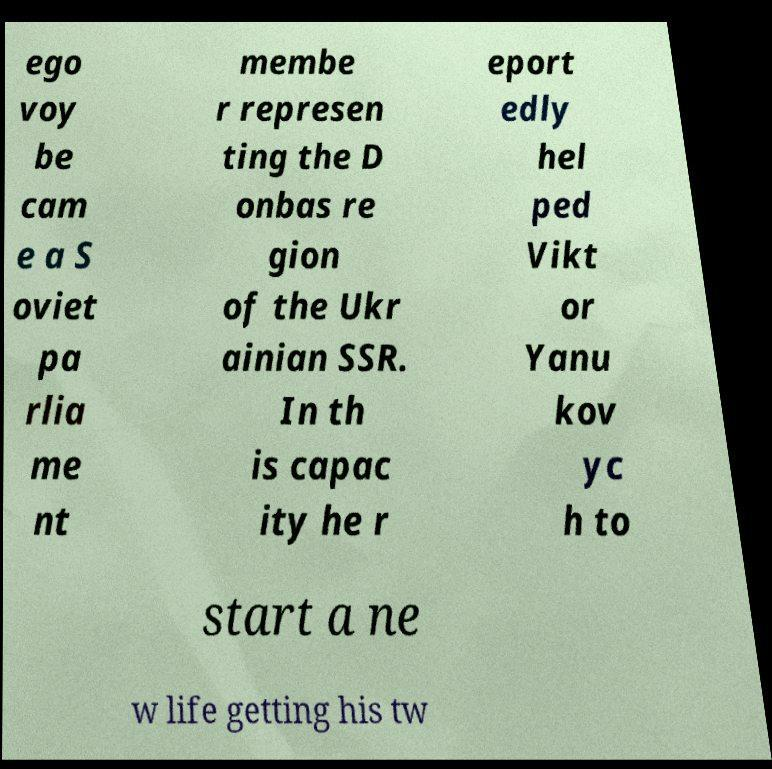Please identify and transcribe the text found in this image. ego voy be cam e a S oviet pa rlia me nt membe r represen ting the D onbas re gion of the Ukr ainian SSR. In th is capac ity he r eport edly hel ped Vikt or Yanu kov yc h to start a ne w life getting his tw 